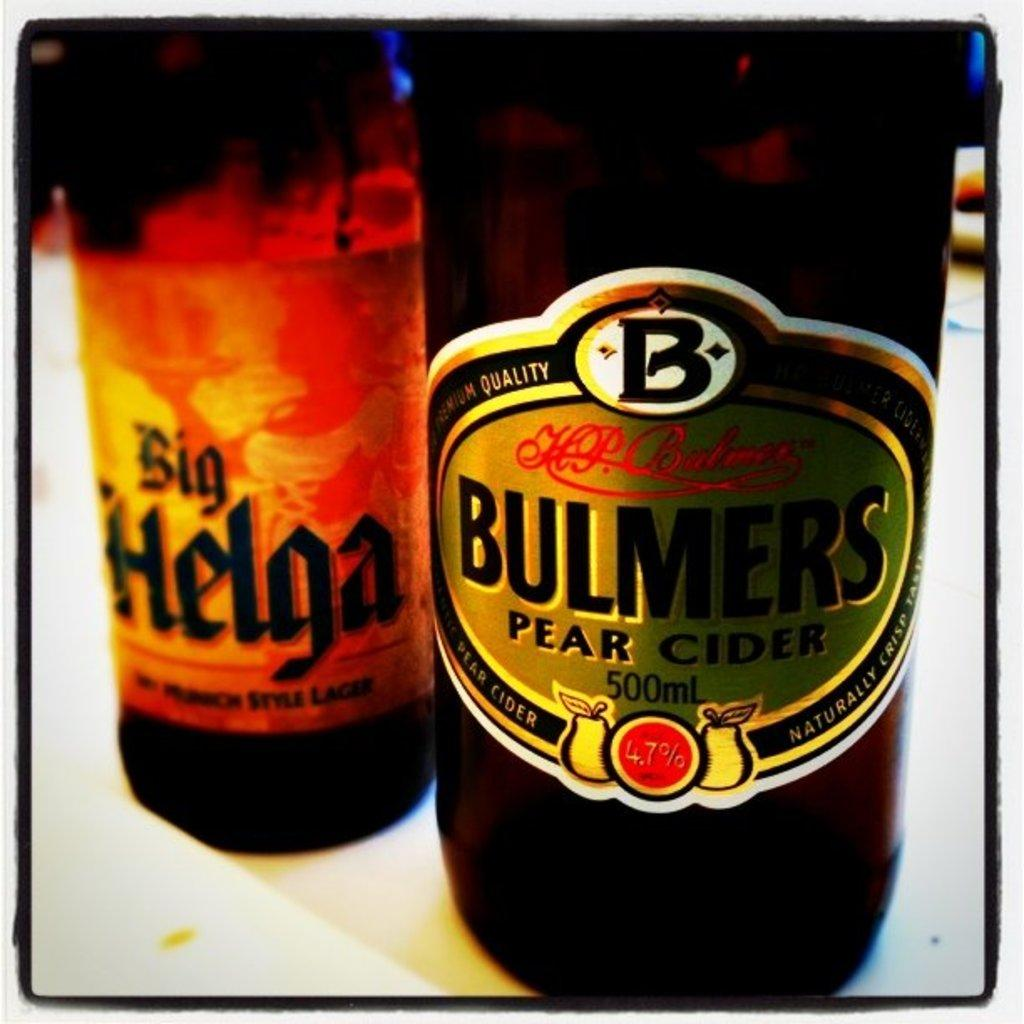Provide a one-sentence caption for the provided image. A bottle of Big Helga is slightlyy behind a bottle of Bulmers Pear Cider. 